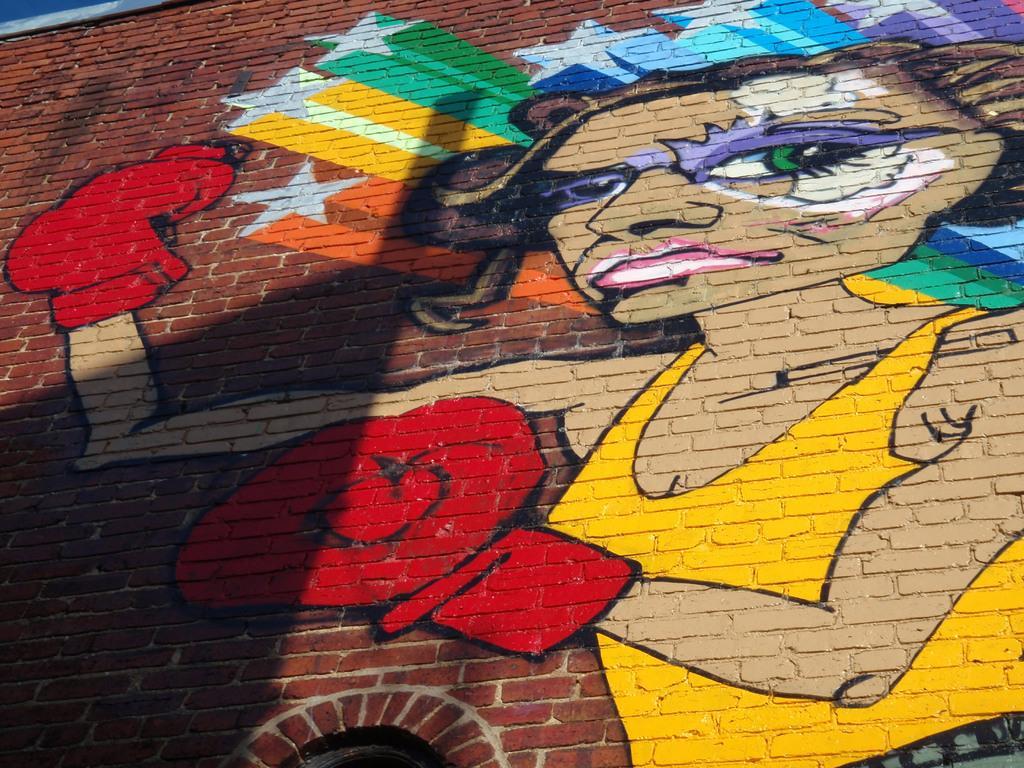Describe this image in one or two sentences. In the picture I can see the painting of a woman wearing the boxing gloves on the brick wall. 